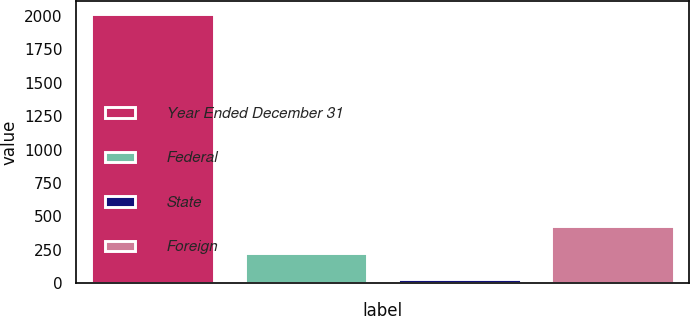Convert chart to OTSL. <chart><loc_0><loc_0><loc_500><loc_500><bar_chart><fcel>Year Ended December 31<fcel>Federal<fcel>State<fcel>Foreign<nl><fcel>2012<fcel>229.55<fcel>31.5<fcel>427.6<nl></chart> 